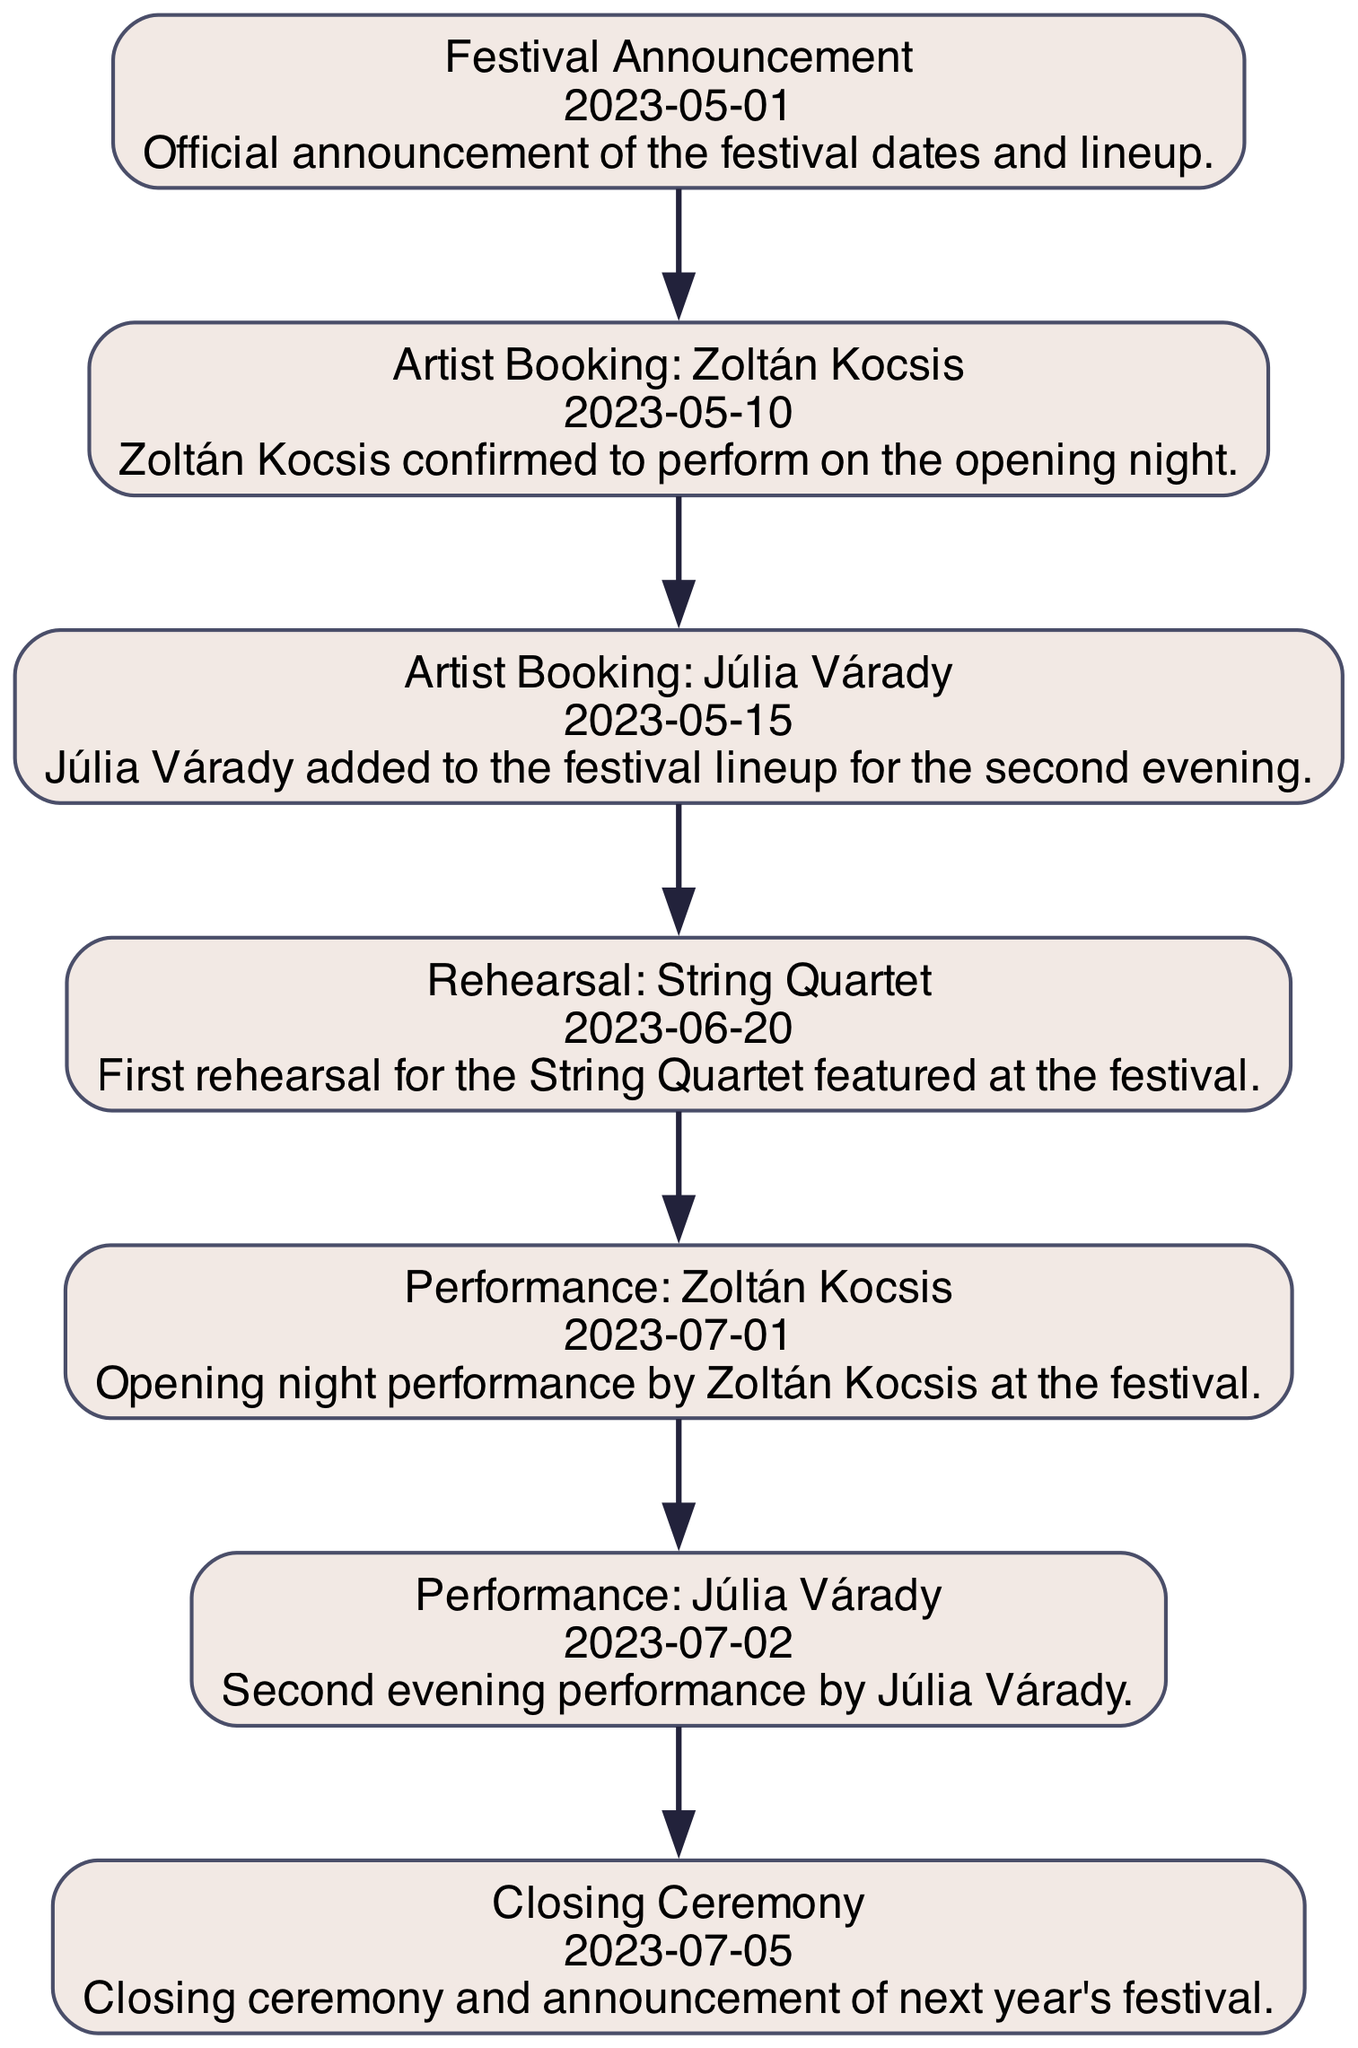What is the first event in the timeline? The first event in the timeline is the "Festival Announcement" which occurs on May 1, 2023. This is indicated as the initial node in the diagram.
Answer: Festival Announcement How many performances are scheduled during the festival? The diagram shows two performance events, one by Zoltán Kocsis and another by Júlia Várady. Both are distinct events that take place on different dates.
Answer: 2 What date is Zoltán Kocsis's performance scheduled? According to the timeline, Zoltán Kocsis's performance is set for July 1, 2023. This information can be found on the node related to his performance.
Answer: July 1, 2023 Which event occurs immediately after the rehearsal for the String Quartet? The event that follows the rehearsal for the String Quartet is the performance by Zoltán Kocsis. This can be observed by tracking the order of events from the rehearsal node to the performance node.
Answer: Performance: Zoltán Kocsis What is the event that marks the end of the festival? The final event in the timeline is the "Closing Ceremony," which signifies the end of the festival and is clearly labeled as the last node.
Answer: Closing Ceremony What is the date of the rehearsal for the String Quartet? The rehearsal for the String Quartet occurs on June 20, 2023, which is stated directly in the node that describes the rehearsal.
Answer: June 20, 2023 Who is performing on the second evening of the festival? Júlia Várady is scheduled to perform on the second evening of the festival, as indicated by the relevant event in the diagram.
Answer: Júlia Várady How many days are there between the festival announcement and the closing ceremony? The festival announcement is on May 1, 2023, and the closing ceremony is on July 5, 2023. Counting the days between these two dates gives a total of 65 days.
Answer: 65 days 